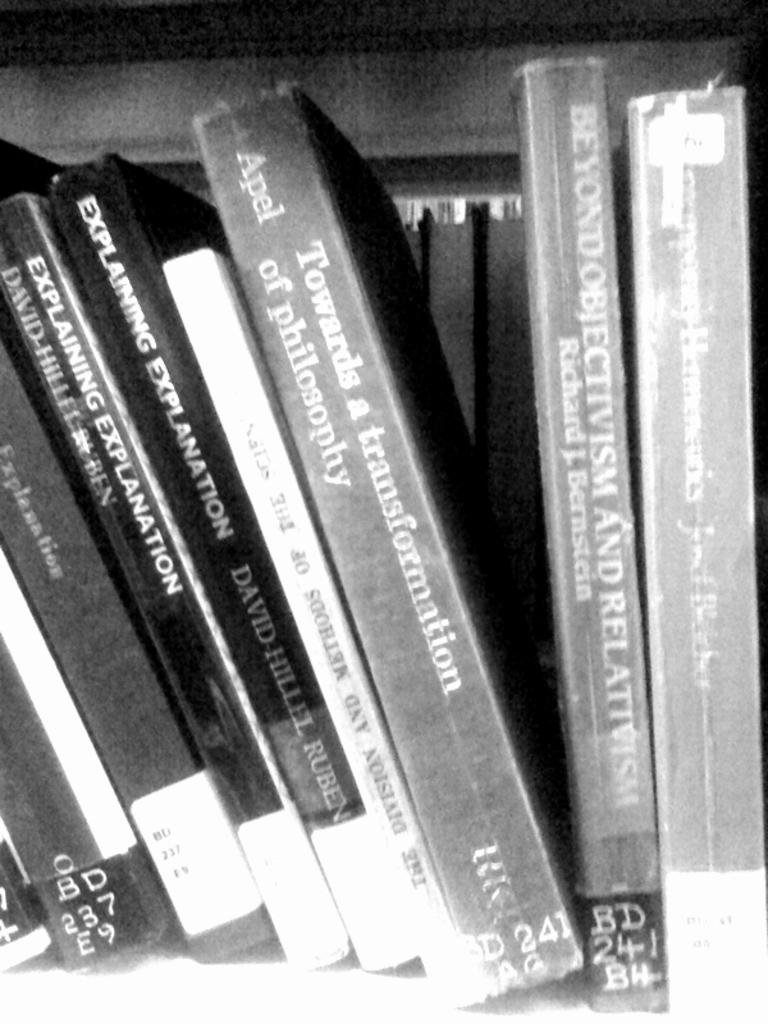Provide a one-sentence caption for the provided image. A book shelf has philosophy books such as Explaining Explanation. 